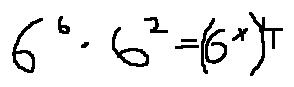Convert formula to latex. <formula><loc_0><loc_0><loc_500><loc_500>6 ^ { 6 } \cdot 6 ^ { 2 } = ( 6 ^ { x } ) ^ { 4 }</formula> 